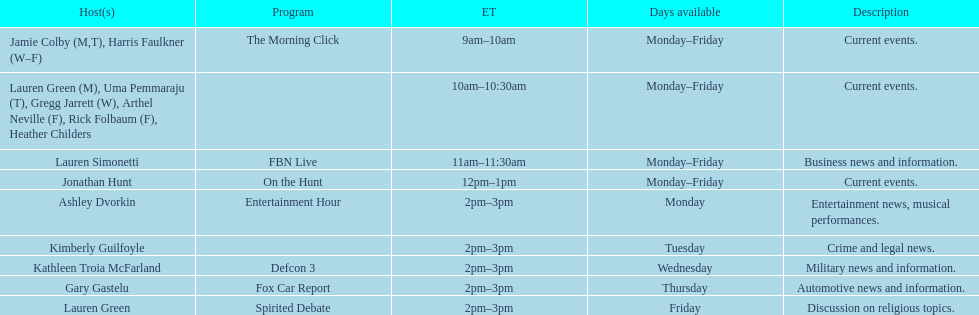What is the first show to play on monday mornings? The Morning Click. Give me the full table as a dictionary. {'header': ['Host(s)', 'Program', 'ET', 'Days available', 'Description'], 'rows': [['Jamie Colby (M,T), Harris Faulkner (W–F)', 'The Morning Click', '9am–10am', 'Monday–Friday', 'Current events.'], ['Lauren Green (M), Uma Pemmaraju (T), Gregg Jarrett (W), Arthel Neville (F), Rick Folbaum (F), Heather Childers', '', '10am–10:30am', 'Monday–Friday', 'Current events.'], ['Lauren Simonetti', 'FBN Live', '11am–11:30am', 'Monday–Friday', 'Business news and information.'], ['Jonathan Hunt', 'On the Hunt', '12pm–1pm', 'Monday–Friday', 'Current events.'], ['Ashley Dvorkin', 'Entertainment Hour', '2pm–3pm', 'Monday', 'Entertainment news, musical performances.'], ['Kimberly Guilfoyle', '', '2pm–3pm', 'Tuesday', 'Crime and legal news.'], ['Kathleen Troia McFarland', 'Defcon 3', '2pm–3pm', 'Wednesday', 'Military news and information.'], ['Gary Gastelu', 'Fox Car Report', '2pm–3pm', 'Thursday', 'Automotive news and information.'], ['Lauren Green', 'Spirited Debate', '2pm–3pm', 'Friday', 'Discussion on religious topics.']]} 